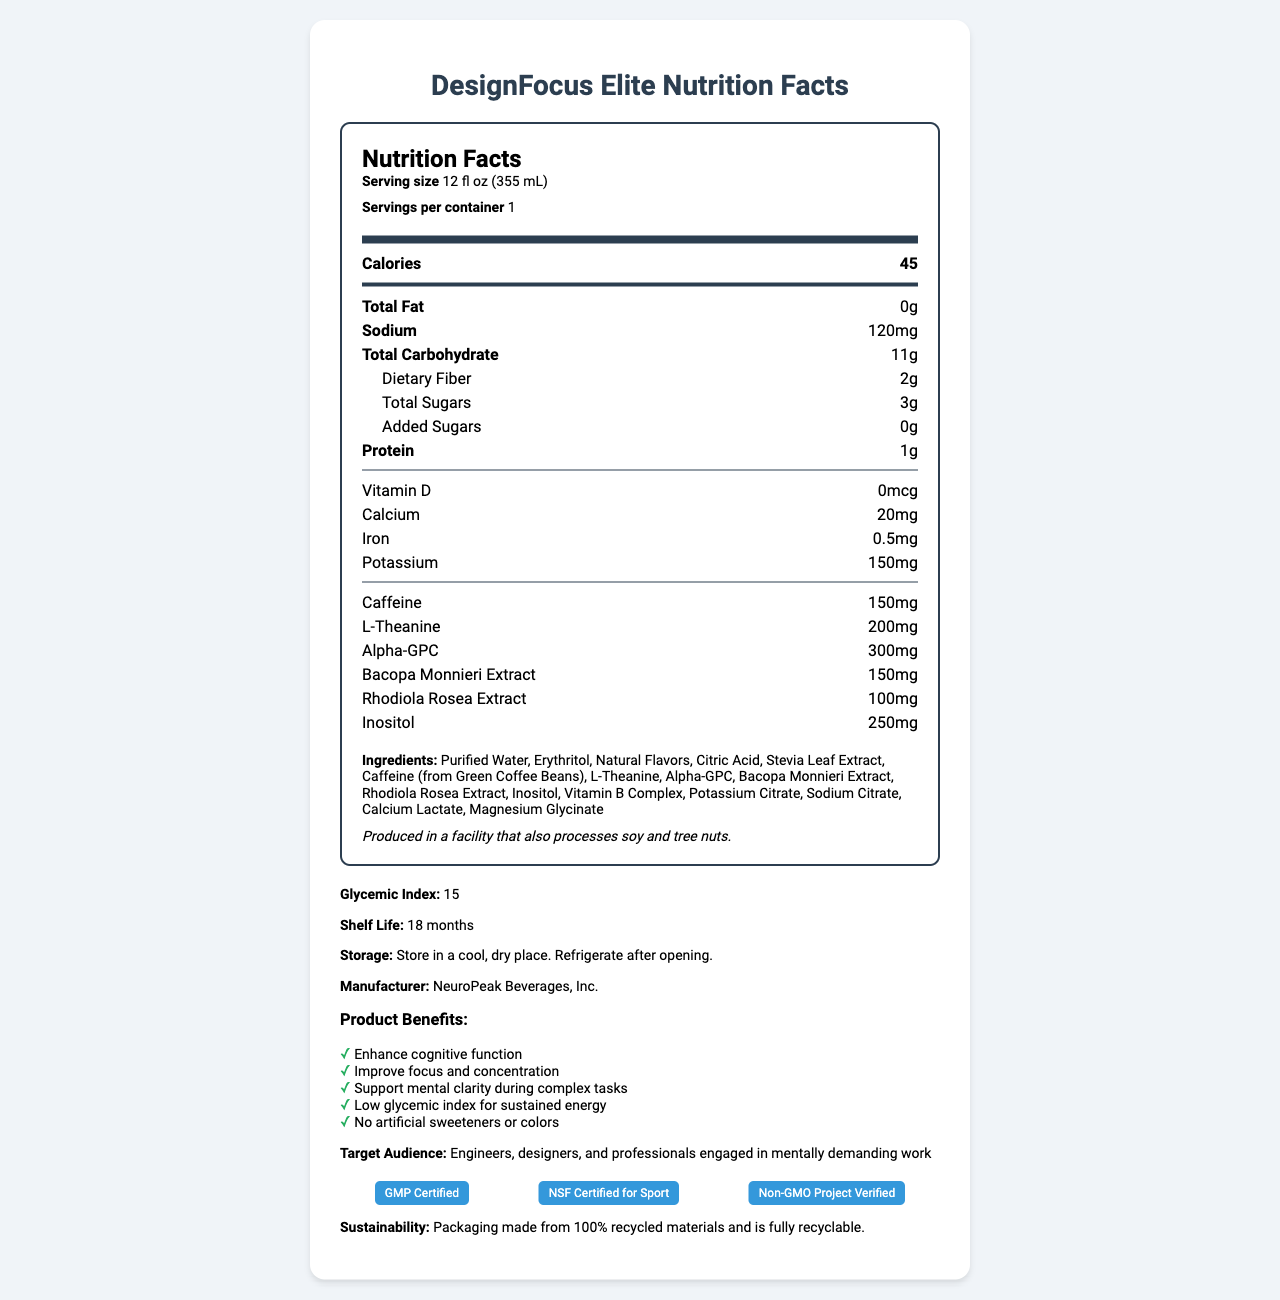How many milligrams of caffeine are in one serving of DesignFocus Elite? The Nutrition Facts label indicates that each serving contains 150mg of caffeine.
Answer: 150mg What is the serving size of DesignFocus Elite? The label states that the serving size is 12 fluid ounces, equivalent to 355 milliliters.
Answer: 12 fl oz (355 mL) What is the glycemic index of DesignFocus Elite? The glycemic index value is listed as 15 on the document.
Answer: 15 How much dietary fiber is present in one serving? The document shows that each serving contains 2 grams of dietary fiber.
Answer: 2g List three ingredients found in DesignFocus Elite. These ingredients are among those listed under the ingredients section.
Answer: Purified Water, Erythritol, Natural Flavors How many calories does one serving of DesignFocus Elite provide? A. 50 B. 45 C. 60 D. 40 The label indicates that one serving provides 45 calories.
Answer: B. 45 Which certification does DesignFocus Elite NOT have? A. GMP Certified B. NSF Certified for Sport C. Non-GMO Project Verified D. USDA Organic The certifications listed are GMP Certified, NSF Certified for Sport, and Non-GMO Project Verified. USDA Organic is not listed.
Answer: D. USDA Organic Is the product intended for mentally demanding work? Yes/No The target audience states that it is designed for engineers, designers, and professionals engaged in mentally demanding work.
Answer: Yes Summarize the main idea of the document. The document details the nutritional content, product benefits, target audience, certifications, and ingredients of DesignFocus Elite, emphasizing its purpose of enhancing cognitive function and sustained energy.
Answer: DesignFocus Elite is a low-glycemic index energy drink formulated to improve focus and cognitive function during complex tasks. It contains key ingredients like caffeine, L-Theanine, and Alpha-GPC, offers various benefits for mental clarity, and carries multiple quality certifications. How long is the shelf life of DesignFocus Elite? The document specifies that the shelf life is 18 months.
Answer: 18 months Which vitamin is not included in the content of DesignFocus Elite? The document lists Vitamin D, Vitamin B6, and Vitamin B12 but does not mention Vitamin C.
Answer: Vitamin C What should you do after opening the container of DesignFocus Elite? The storage instructions specify to refrigerate the product after opening.
Answer: Refrigerate after opening Which company manufactures DesignFocus Elite? The manufacturer is listed as NeuroPeak Beverages, Inc.
Answer: NeuroPeak Beverages, Inc. Can you determine how many calories come from fat in DesignFocus Elite? The document lists the total calories and total fat content, but it does not specify how many calories come specifically from fat.
Answer: Cannot be determined 